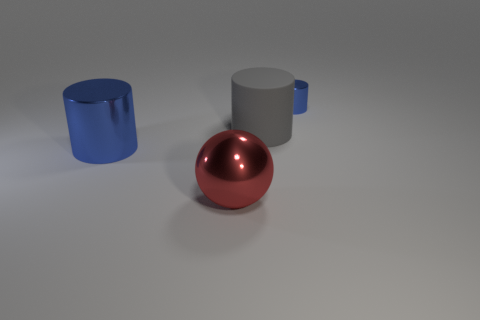How many objects are there?
Offer a terse response. 4. What number of small cylinders are the same color as the big sphere?
Your answer should be compact. 0. There is a blue metal object that is right of the large red shiny ball; is it the same shape as the gray thing to the left of the small blue metal object?
Keep it short and to the point. Yes. What is the color of the large cylinder that is behind the blue metal thing on the left side of the blue metallic cylinder that is to the right of the large sphere?
Your response must be concise. Gray. There is a big thing in front of the large shiny cylinder; what color is it?
Your answer should be very brief. Red. There is a rubber thing that is the same size as the ball; what color is it?
Offer a terse response. Gray. Do the red thing and the gray object have the same size?
Give a very brief answer. Yes. There is a gray object; what number of blue things are to the left of it?
Provide a short and direct response. 1. What number of things are either big objects that are on the left side of the big red thing or brown spheres?
Provide a short and direct response. 1. Are there more gray cylinders behind the matte thing than big gray cylinders in front of the metal sphere?
Give a very brief answer. No. 